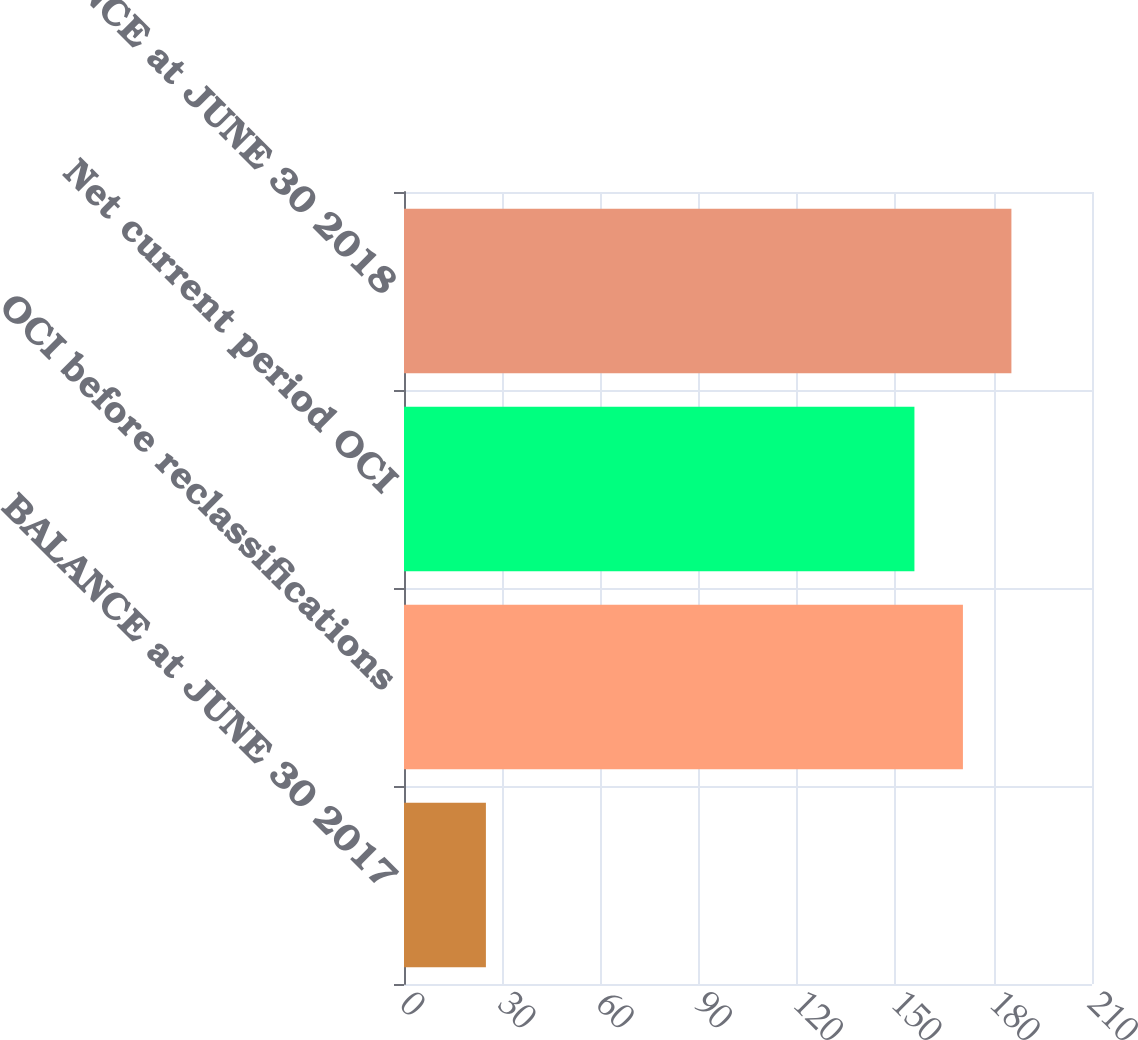<chart> <loc_0><loc_0><loc_500><loc_500><bar_chart><fcel>BALANCE at JUNE 30 2017<fcel>OCI before reclassifications<fcel>Net current period OCI<fcel>BALANCE at JUNE 30 2018<nl><fcel>25<fcel>170.6<fcel>155.8<fcel>185.4<nl></chart> 